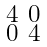<formula> <loc_0><loc_0><loc_500><loc_500>\begin{smallmatrix} 4 & 0 \\ 0 & 4 \end{smallmatrix}</formula> 